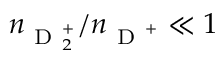Convert formula to latex. <formula><loc_0><loc_0><loc_500><loc_500>n _ { D _ { 2 } ^ { + } } / n _ { D ^ { + } } \ll 1</formula> 